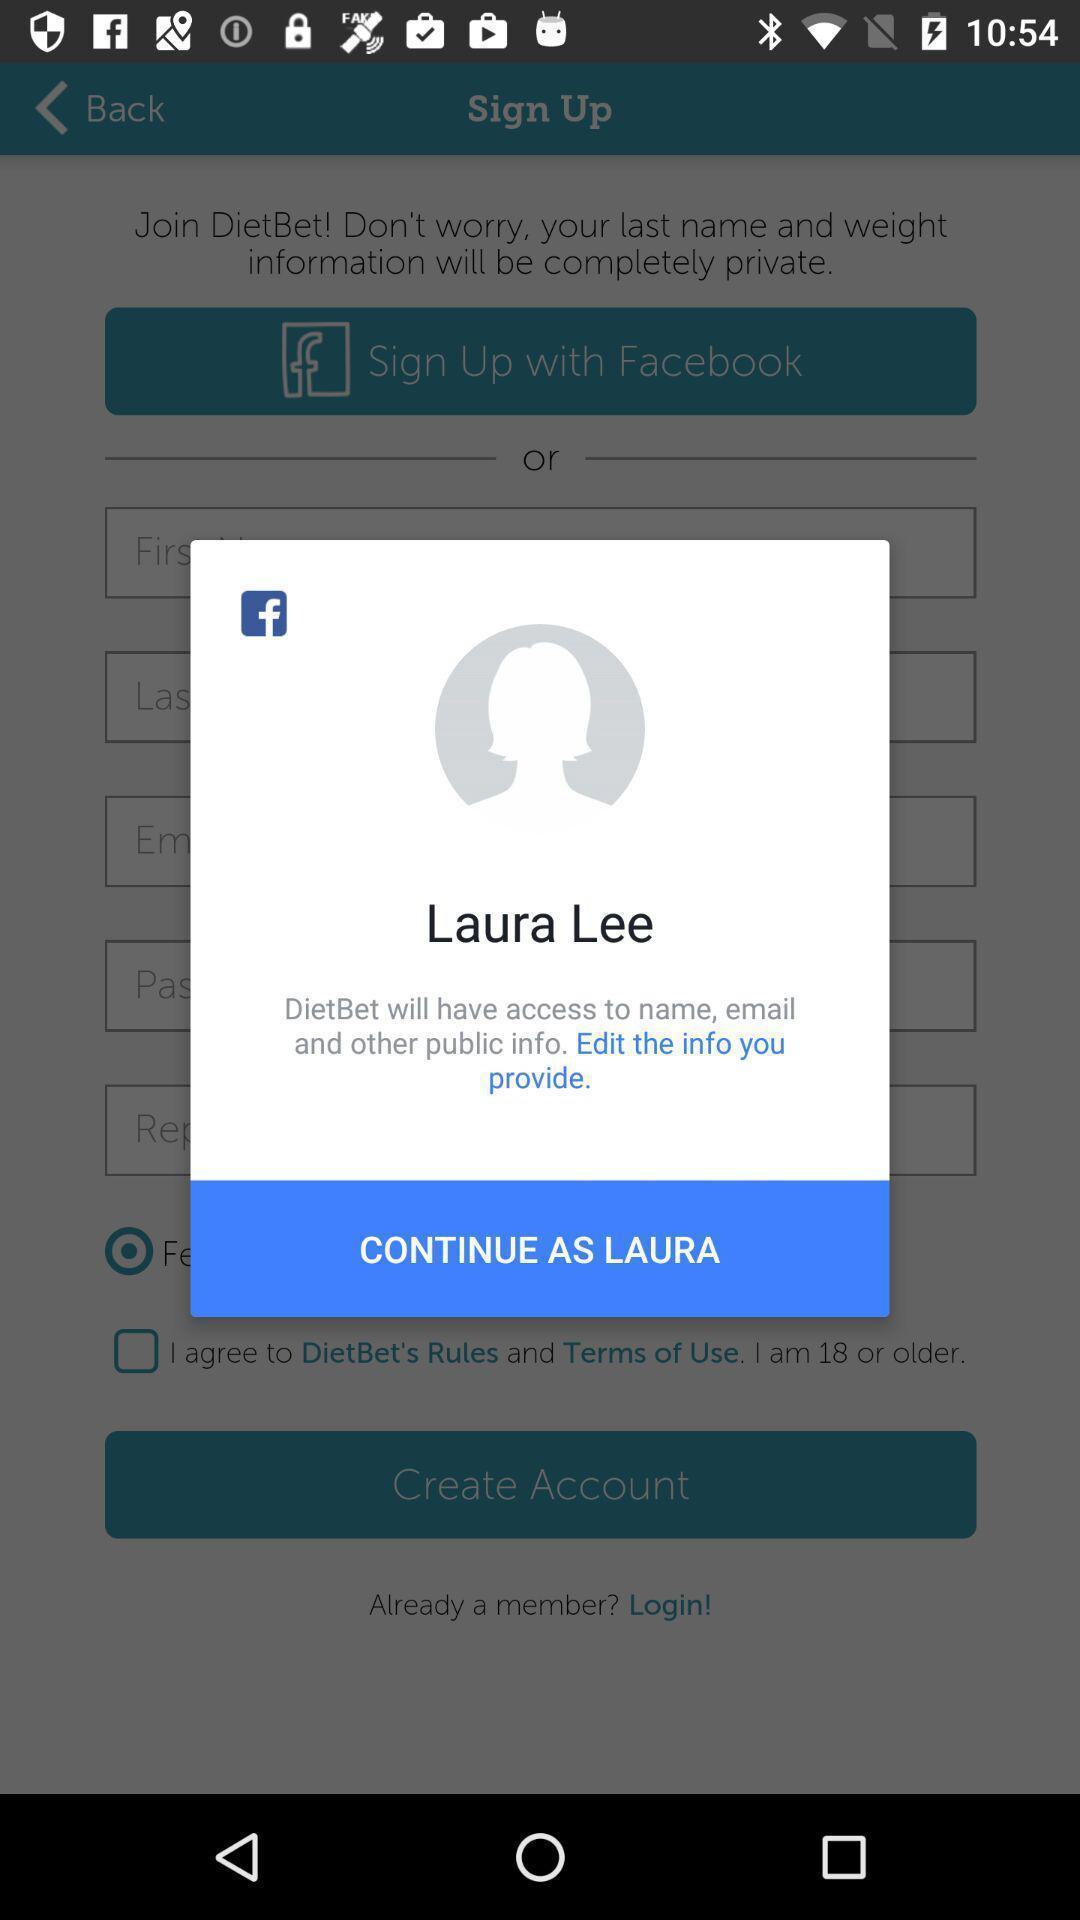Give me a narrative description of this picture. Pop-up displaying to continue in app. 